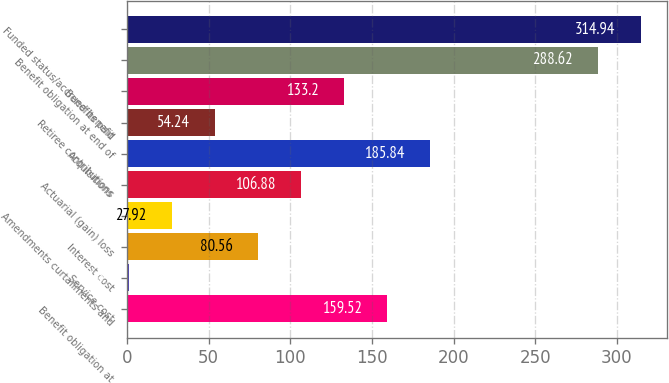<chart> <loc_0><loc_0><loc_500><loc_500><bar_chart><fcel>Benefit obligation at<fcel>Service cost<fcel>Interest cost<fcel>Amendments curtailments and<fcel>Actuarial (gain) loss<fcel>Acquisitions<fcel>Retiree contributions<fcel>Benefits paid<fcel>Benefit obligation at end of<fcel>Funded status/accrued benefit<nl><fcel>159.52<fcel>1.6<fcel>80.56<fcel>27.92<fcel>106.88<fcel>185.84<fcel>54.24<fcel>133.2<fcel>288.62<fcel>314.94<nl></chart> 